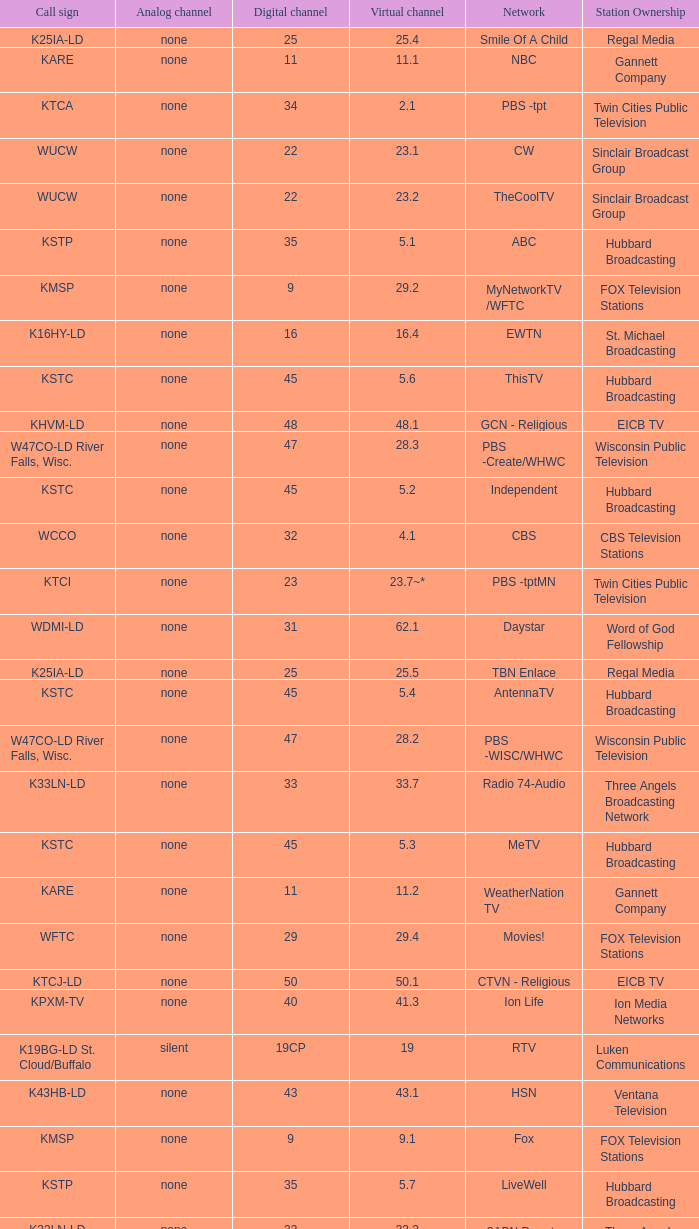Call sign of k33ln-ld, and a Virtual channel of 33.5 is what network? 3ABN Radio-Audio. 